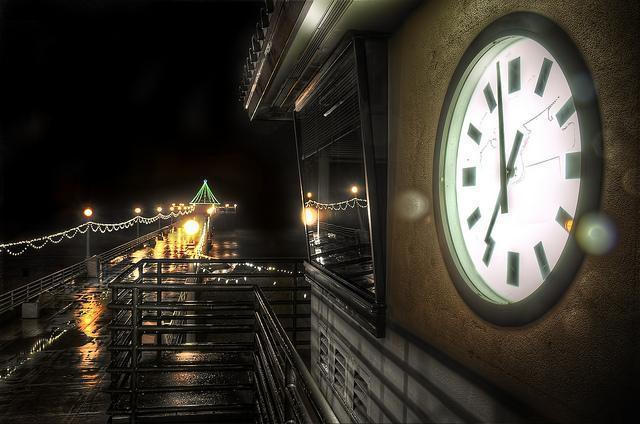How many men are wearing hats?
Give a very brief answer. 0. 